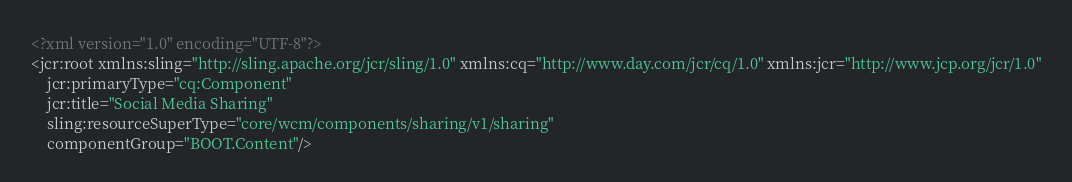Convert code to text. <code><loc_0><loc_0><loc_500><loc_500><_XML_><?xml version="1.0" encoding="UTF-8"?>
<jcr:root xmlns:sling="http://sling.apache.org/jcr/sling/1.0" xmlns:cq="http://www.day.com/jcr/cq/1.0" xmlns:jcr="http://www.jcp.org/jcr/1.0"
    jcr:primaryType="cq:Component"
    jcr:title="Social Media Sharing"
    sling:resourceSuperType="core/wcm/components/sharing/v1/sharing"
    componentGroup="BOOT.Content"/>
</code> 